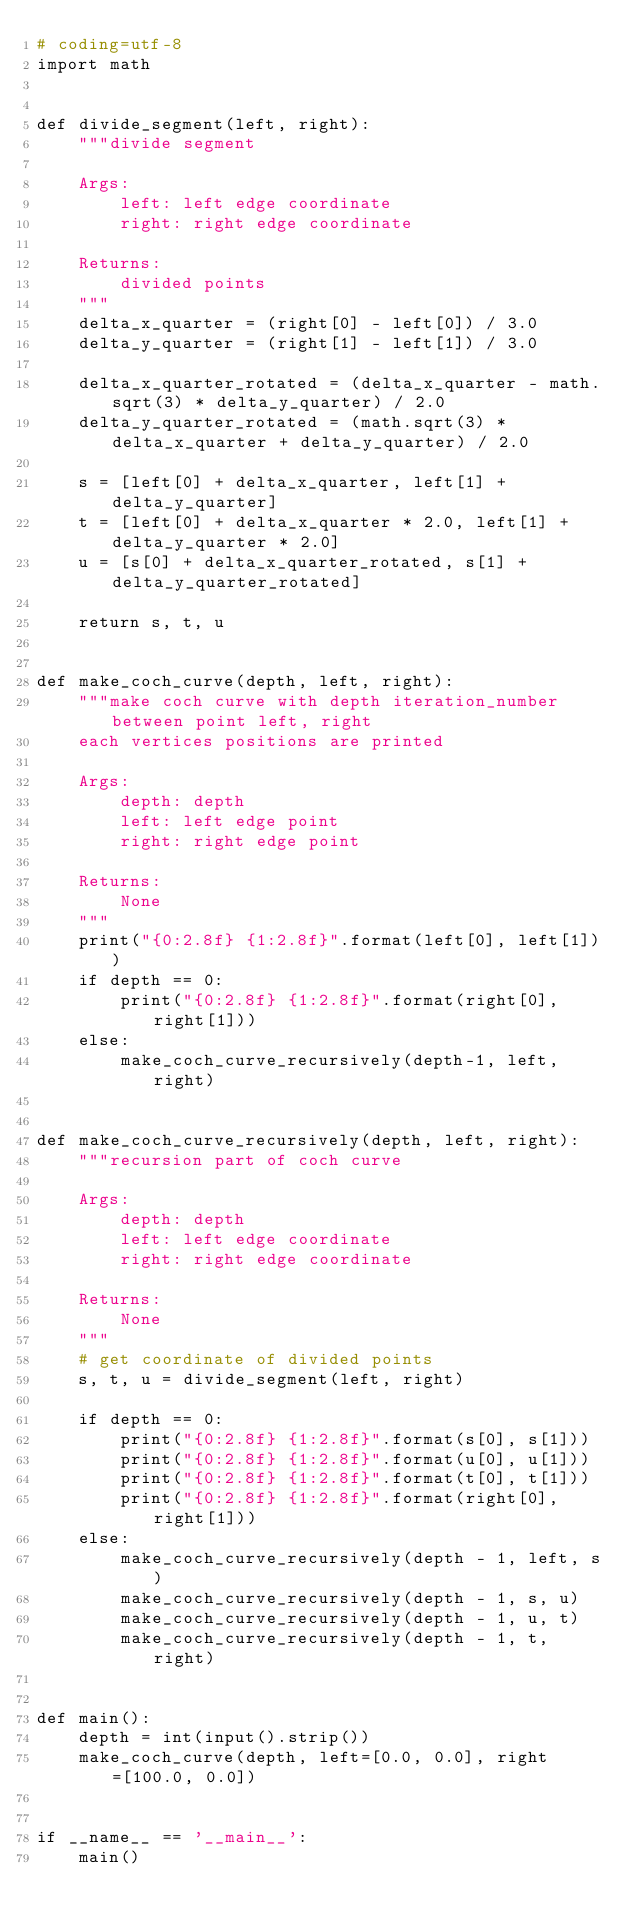<code> <loc_0><loc_0><loc_500><loc_500><_Python_># coding=utf-8
import math


def divide_segment(left, right):
    """divide segment

    Args:
        left: left edge coordinate
        right: right edge coordinate

    Returns:
        divided points
    """
    delta_x_quarter = (right[0] - left[0]) / 3.0
    delta_y_quarter = (right[1] - left[1]) / 3.0

    delta_x_quarter_rotated = (delta_x_quarter - math.sqrt(3) * delta_y_quarter) / 2.0
    delta_y_quarter_rotated = (math.sqrt(3) * delta_x_quarter + delta_y_quarter) / 2.0

    s = [left[0] + delta_x_quarter, left[1] + delta_y_quarter]
    t = [left[0] + delta_x_quarter * 2.0, left[1] + delta_y_quarter * 2.0]
    u = [s[0] + delta_x_quarter_rotated, s[1] + delta_y_quarter_rotated]

    return s, t, u


def make_coch_curve(depth, left, right):
    """make coch curve with depth iteration_number between point left, right
    each vertices positions are printed

    Args:
        depth: depth
        left: left edge point
        right: right edge point

    Returns:
        None
    """
    print("{0:2.8f} {1:2.8f}".format(left[0], left[1]))
    if depth == 0:
        print("{0:2.8f} {1:2.8f}".format(right[0], right[1]))
    else:
        make_coch_curve_recursively(depth-1, left, right)


def make_coch_curve_recursively(depth, left, right):
    """recursion part of coch curve

    Args:
        depth: depth
        left: left edge coordinate
        right: right edge coordinate

    Returns:
        None
    """
    # get coordinate of divided points
    s, t, u = divide_segment(left, right)

    if depth == 0:
        print("{0:2.8f} {1:2.8f}".format(s[0], s[1]))
        print("{0:2.8f} {1:2.8f}".format(u[0], u[1]))
        print("{0:2.8f} {1:2.8f}".format(t[0], t[1]))
        print("{0:2.8f} {1:2.8f}".format(right[0], right[1]))
    else:
        make_coch_curve_recursively(depth - 1, left, s)
        make_coch_curve_recursively(depth - 1, s, u)
        make_coch_curve_recursively(depth - 1, u, t)
        make_coch_curve_recursively(depth - 1, t, right)


def main():
    depth = int(input().strip())
    make_coch_curve(depth, left=[0.0, 0.0], right=[100.0, 0.0])


if __name__ == '__main__':
    main()</code> 